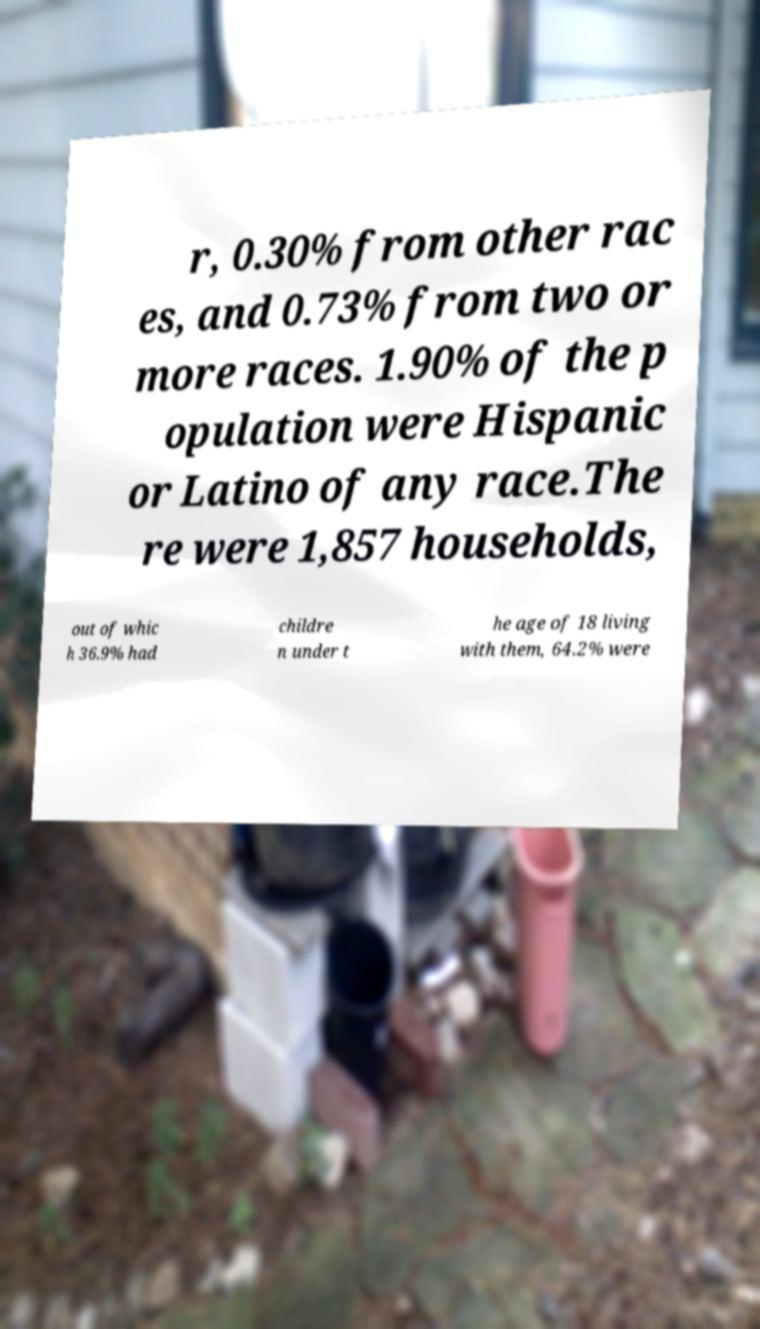Please identify and transcribe the text found in this image. r, 0.30% from other rac es, and 0.73% from two or more races. 1.90% of the p opulation were Hispanic or Latino of any race.The re were 1,857 households, out of whic h 36.9% had childre n under t he age of 18 living with them, 64.2% were 